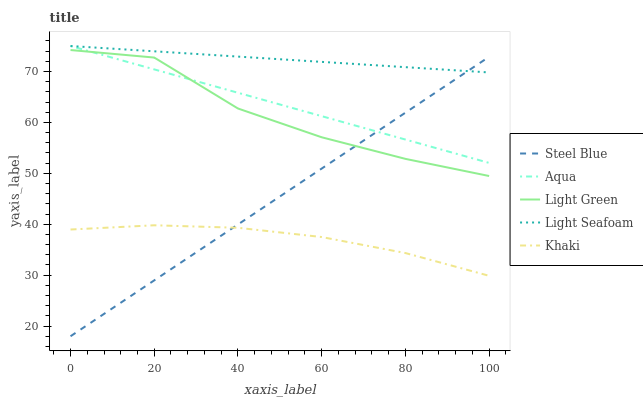Does Khaki have the minimum area under the curve?
Answer yes or no. Yes. Does Light Seafoam have the maximum area under the curve?
Answer yes or no. Yes. Does Aqua have the minimum area under the curve?
Answer yes or no. No. Does Aqua have the maximum area under the curve?
Answer yes or no. No. Is Light Seafoam the smoothest?
Answer yes or no. Yes. Is Light Green the roughest?
Answer yes or no. Yes. Is Aqua the smoothest?
Answer yes or no. No. Is Aqua the roughest?
Answer yes or no. No. Does Aqua have the lowest value?
Answer yes or no. No. Does Aqua have the highest value?
Answer yes or no. Yes. Does Steel Blue have the highest value?
Answer yes or no. No. Is Light Green less than Light Seafoam?
Answer yes or no. Yes. Is Aqua greater than Khaki?
Answer yes or no. Yes. Does Steel Blue intersect Light Green?
Answer yes or no. Yes. Is Steel Blue less than Light Green?
Answer yes or no. No. Is Steel Blue greater than Light Green?
Answer yes or no. No. Does Light Green intersect Light Seafoam?
Answer yes or no. No. 